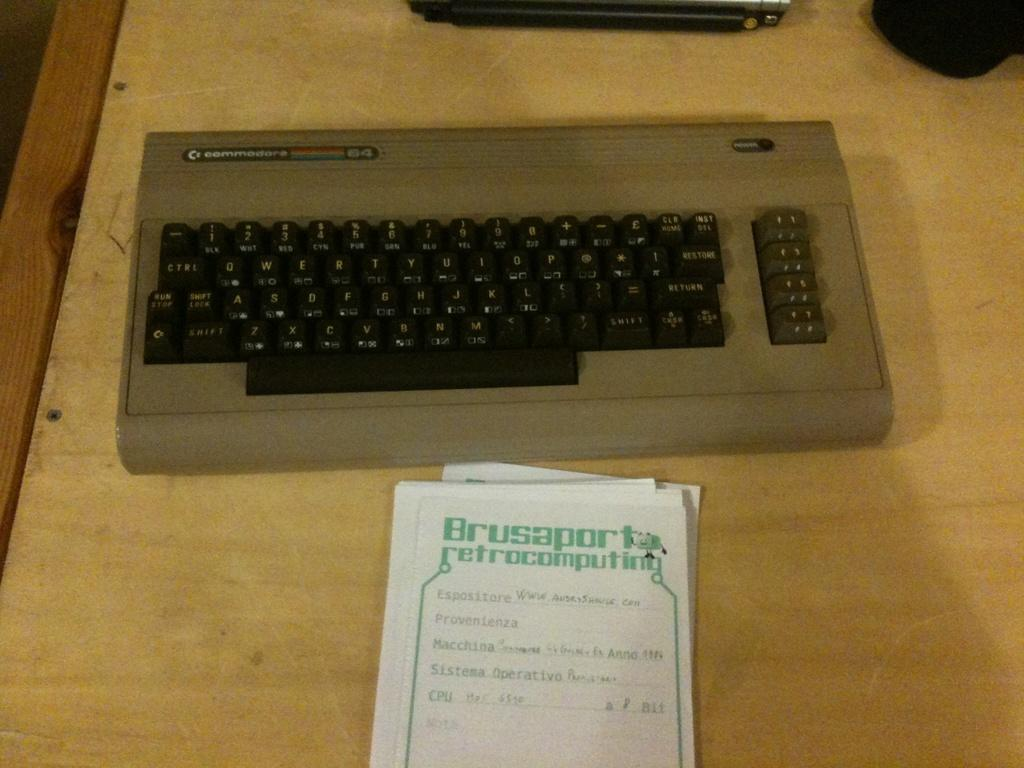<image>
Relay a brief, clear account of the picture shown. A Commodore keyboard on a desk with a small stack of notes. 